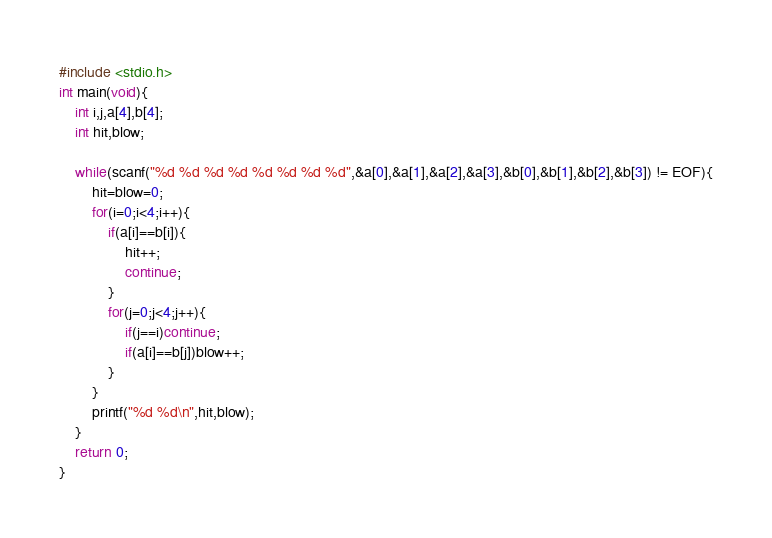<code> <loc_0><loc_0><loc_500><loc_500><_C_>#include <stdio.h>
int main(void){
    int i,j,a[4],b[4];
    int hit,blow;
    
    while(scanf("%d %d %d %d %d %d %d %d",&a[0],&a[1],&a[2],&a[3],&b[0],&b[1],&b[2],&b[3]) != EOF){
        hit=blow=0;
        for(i=0;i<4;i++){
            if(a[i]==b[i]){
                hit++;
                continue;
            }
            for(j=0;j<4;j++){
                if(j==i)continue;
                if(a[i]==b[j])blow++;
            }
        }
        printf("%d %d\n",hit,blow);
    }
    return 0;
}</code> 